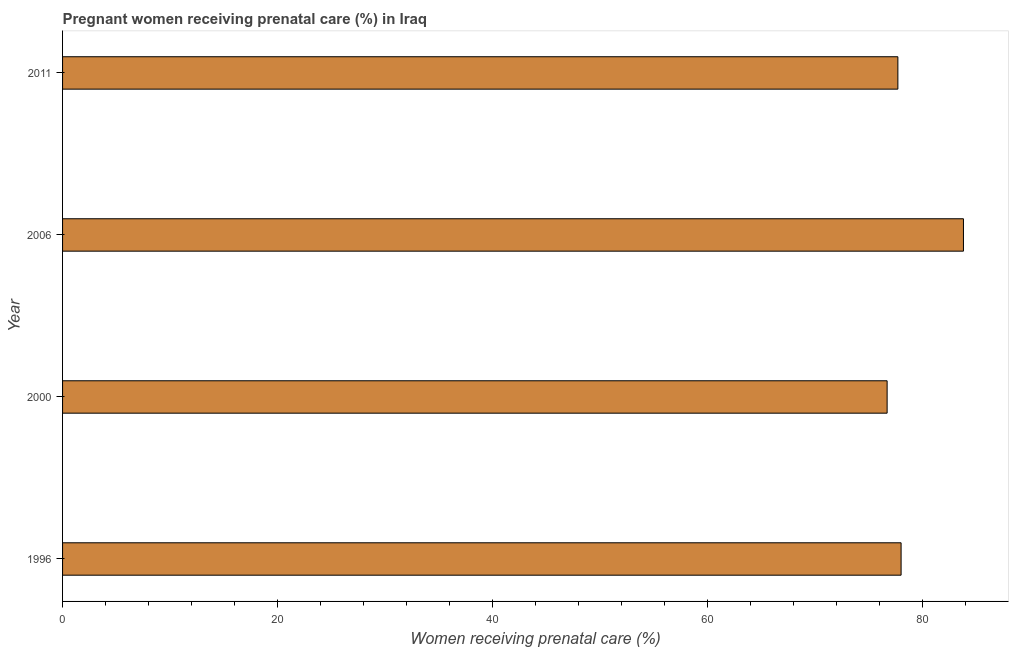Does the graph contain grids?
Your response must be concise. No. What is the title of the graph?
Provide a succinct answer. Pregnant women receiving prenatal care (%) in Iraq. What is the label or title of the X-axis?
Offer a terse response. Women receiving prenatal care (%). What is the label or title of the Y-axis?
Your answer should be compact. Year. What is the percentage of pregnant women receiving prenatal care in 1996?
Offer a terse response. 78. Across all years, what is the maximum percentage of pregnant women receiving prenatal care?
Ensure brevity in your answer.  83.8. Across all years, what is the minimum percentage of pregnant women receiving prenatal care?
Offer a terse response. 76.7. In which year was the percentage of pregnant women receiving prenatal care minimum?
Your answer should be compact. 2000. What is the sum of the percentage of pregnant women receiving prenatal care?
Give a very brief answer. 316.2. What is the difference between the percentage of pregnant women receiving prenatal care in 1996 and 2000?
Give a very brief answer. 1.3. What is the average percentage of pregnant women receiving prenatal care per year?
Make the answer very short. 79.05. What is the median percentage of pregnant women receiving prenatal care?
Offer a very short reply. 77.85. Do a majority of the years between 2006 and 2011 (inclusive) have percentage of pregnant women receiving prenatal care greater than 52 %?
Your answer should be compact. Yes. What is the ratio of the percentage of pregnant women receiving prenatal care in 1996 to that in 2011?
Provide a succinct answer. 1. Is the percentage of pregnant women receiving prenatal care in 1996 less than that in 2000?
Provide a succinct answer. No. Is the difference between the percentage of pregnant women receiving prenatal care in 1996 and 2000 greater than the difference between any two years?
Make the answer very short. No. What is the difference between the highest and the lowest percentage of pregnant women receiving prenatal care?
Your response must be concise. 7.1. In how many years, is the percentage of pregnant women receiving prenatal care greater than the average percentage of pregnant women receiving prenatal care taken over all years?
Provide a short and direct response. 1. What is the difference between two consecutive major ticks on the X-axis?
Offer a terse response. 20. What is the Women receiving prenatal care (%) of 1996?
Your response must be concise. 78. What is the Women receiving prenatal care (%) in 2000?
Offer a very short reply. 76.7. What is the Women receiving prenatal care (%) in 2006?
Give a very brief answer. 83.8. What is the Women receiving prenatal care (%) of 2011?
Keep it short and to the point. 77.7. What is the difference between the Women receiving prenatal care (%) in 1996 and 2000?
Your response must be concise. 1.3. What is the difference between the Women receiving prenatal care (%) in 1996 and 2006?
Your response must be concise. -5.8. What is the difference between the Women receiving prenatal care (%) in 2000 and 2011?
Your response must be concise. -1. What is the difference between the Women receiving prenatal care (%) in 2006 and 2011?
Your response must be concise. 6.1. What is the ratio of the Women receiving prenatal care (%) in 1996 to that in 2000?
Make the answer very short. 1.02. What is the ratio of the Women receiving prenatal care (%) in 1996 to that in 2006?
Give a very brief answer. 0.93. What is the ratio of the Women receiving prenatal care (%) in 2000 to that in 2006?
Provide a succinct answer. 0.92. What is the ratio of the Women receiving prenatal care (%) in 2006 to that in 2011?
Give a very brief answer. 1.08. 